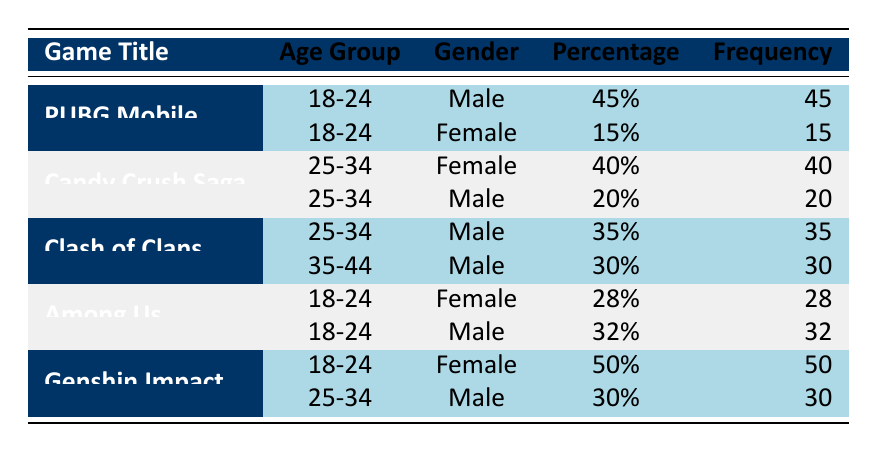What is the percentage of male players in PUBG Mobile aged 18-24? The table shows that within the game PUBG Mobile, the percentage of male players in the age group 18-24 is listed as 45%.
Answer: 45% What is the total percentage of female players in Candy Crush Saga? The table indicates that Candy Crush Saga has 40% female players aged 25-34. There are no other female demographics listed for Candy Crush Saga, so the total percentage of female players is 40%.
Answer: 40% Is the percentage of female players in Among Us greater than that in Clash of Clans for the same age group? Among Us has 28% female players in the age group 18-24, while Clash of Clans does not have any female players listed for that age group. Therefore, 28% is greater than 0%.
Answer: Yes What is the most popular age group for male players in Clash of Clans? Analyzing the data for Clash of Clans, the age group 25-34 has 35% male players, while the age group 35-44 has 30%. Thus, the most popular age group for male players in Clash of Clans is 25-34.
Answer: 25-34 Calculate the average percentage of male players across all games listed in the table. The table has male player percentages for PUBG Mobile (45% + 15%), Candy Crush Saga (20%), Clash of Clans (35% + 30%), Among Us (32%), and Genshin Impact (30%). Summing those gives 45 + 20 + 35 + 30 + 32 = 162. There are 5 entries for males giving an average of 162/5 = 32.4%.
Answer: 32.4% How many total male players are there across all games mentioned? The total frequency for male players across all games is calculated by adding the frequencies from each age group and gender for the male category: 45 (PUBG) + 20 (Candy Crush) + 35 (Clash 25-34) + 30 (Clash 35-44) + 32 (Among Us) + 30 (Genshin) = 192.
Answer: 192 